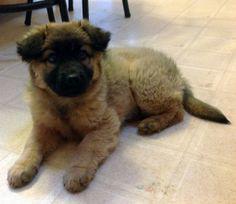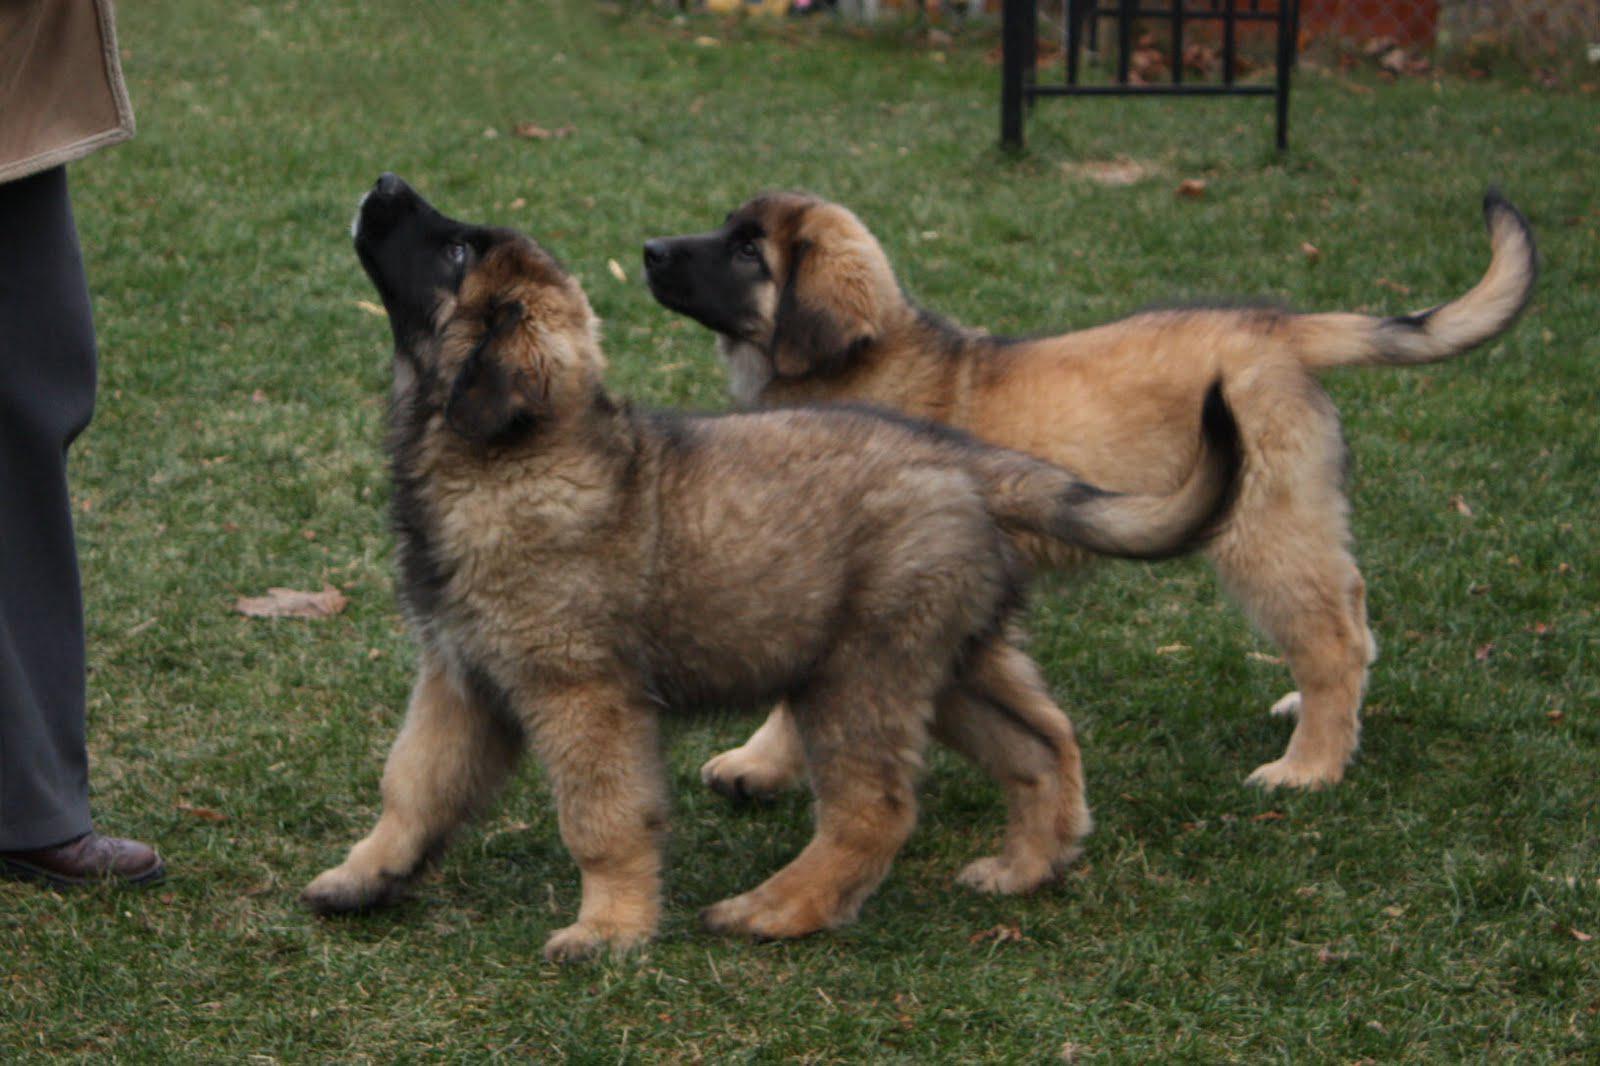The first image is the image on the left, the second image is the image on the right. Assess this claim about the two images: "In one image, three dogs are shown together on a ground containing water in one of its states of matter.". Correct or not? Answer yes or no. No. The first image is the image on the left, the second image is the image on the right. Considering the images on both sides, is "There are two dogs outside in the grass in one of the images." valid? Answer yes or no. Yes. 